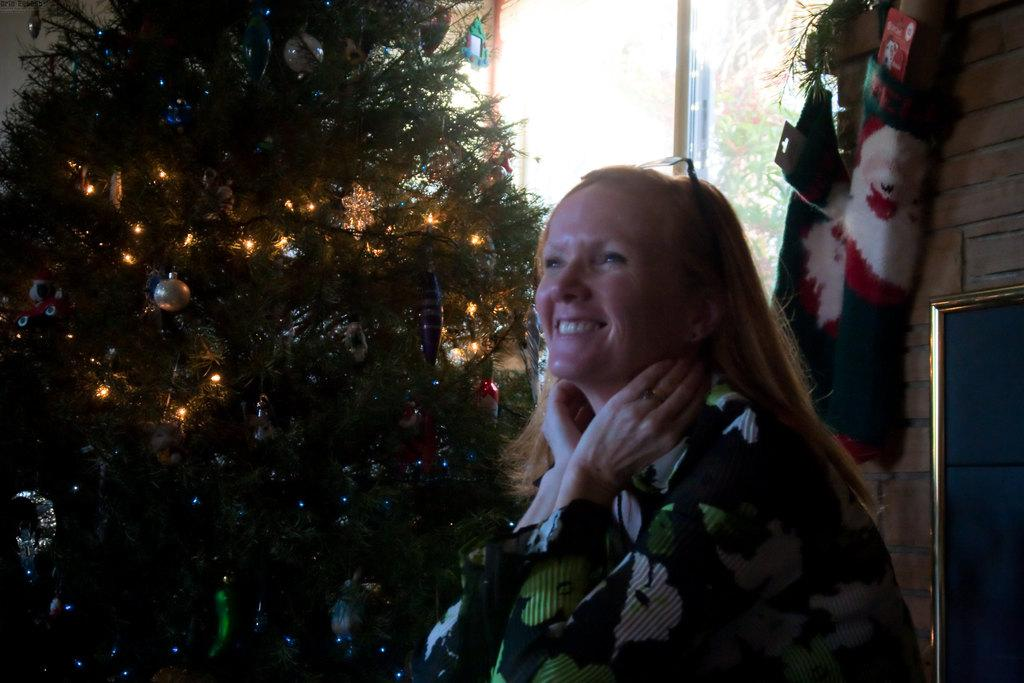Who is present in the image? There is a lady standing in the image. What is the lady doing in the image? The lady is smiling. What is a prominent feature in the background of the image? There is an xmas tree in the image. What is located on the right side of the image? There is a door on the right side of the image. What else can be seen in the image besides the lady and the xmas tree? Decorations are visible in the image. What type of corn can be seen growing in the image? There is no corn present in the image. How many beds are visible in the image? There are no beds visible in the image. 